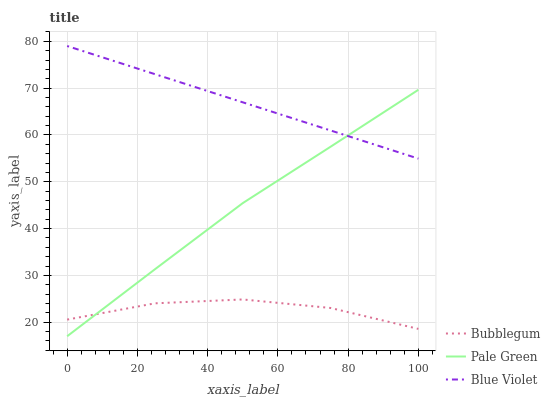Does Bubblegum have the minimum area under the curve?
Answer yes or no. Yes. Does Blue Violet have the maximum area under the curve?
Answer yes or no. Yes. Does Blue Violet have the minimum area under the curve?
Answer yes or no. No. Does Bubblegum have the maximum area under the curve?
Answer yes or no. No. Is Blue Violet the smoothest?
Answer yes or no. Yes. Is Bubblegum the roughest?
Answer yes or no. Yes. Is Bubblegum the smoothest?
Answer yes or no. No. Is Blue Violet the roughest?
Answer yes or no. No. Does Bubblegum have the lowest value?
Answer yes or no. No. Does Blue Violet have the highest value?
Answer yes or no. Yes. Does Bubblegum have the highest value?
Answer yes or no. No. Is Bubblegum less than Blue Violet?
Answer yes or no. Yes. Is Blue Violet greater than Bubblegum?
Answer yes or no. Yes. Does Bubblegum intersect Blue Violet?
Answer yes or no. No. 